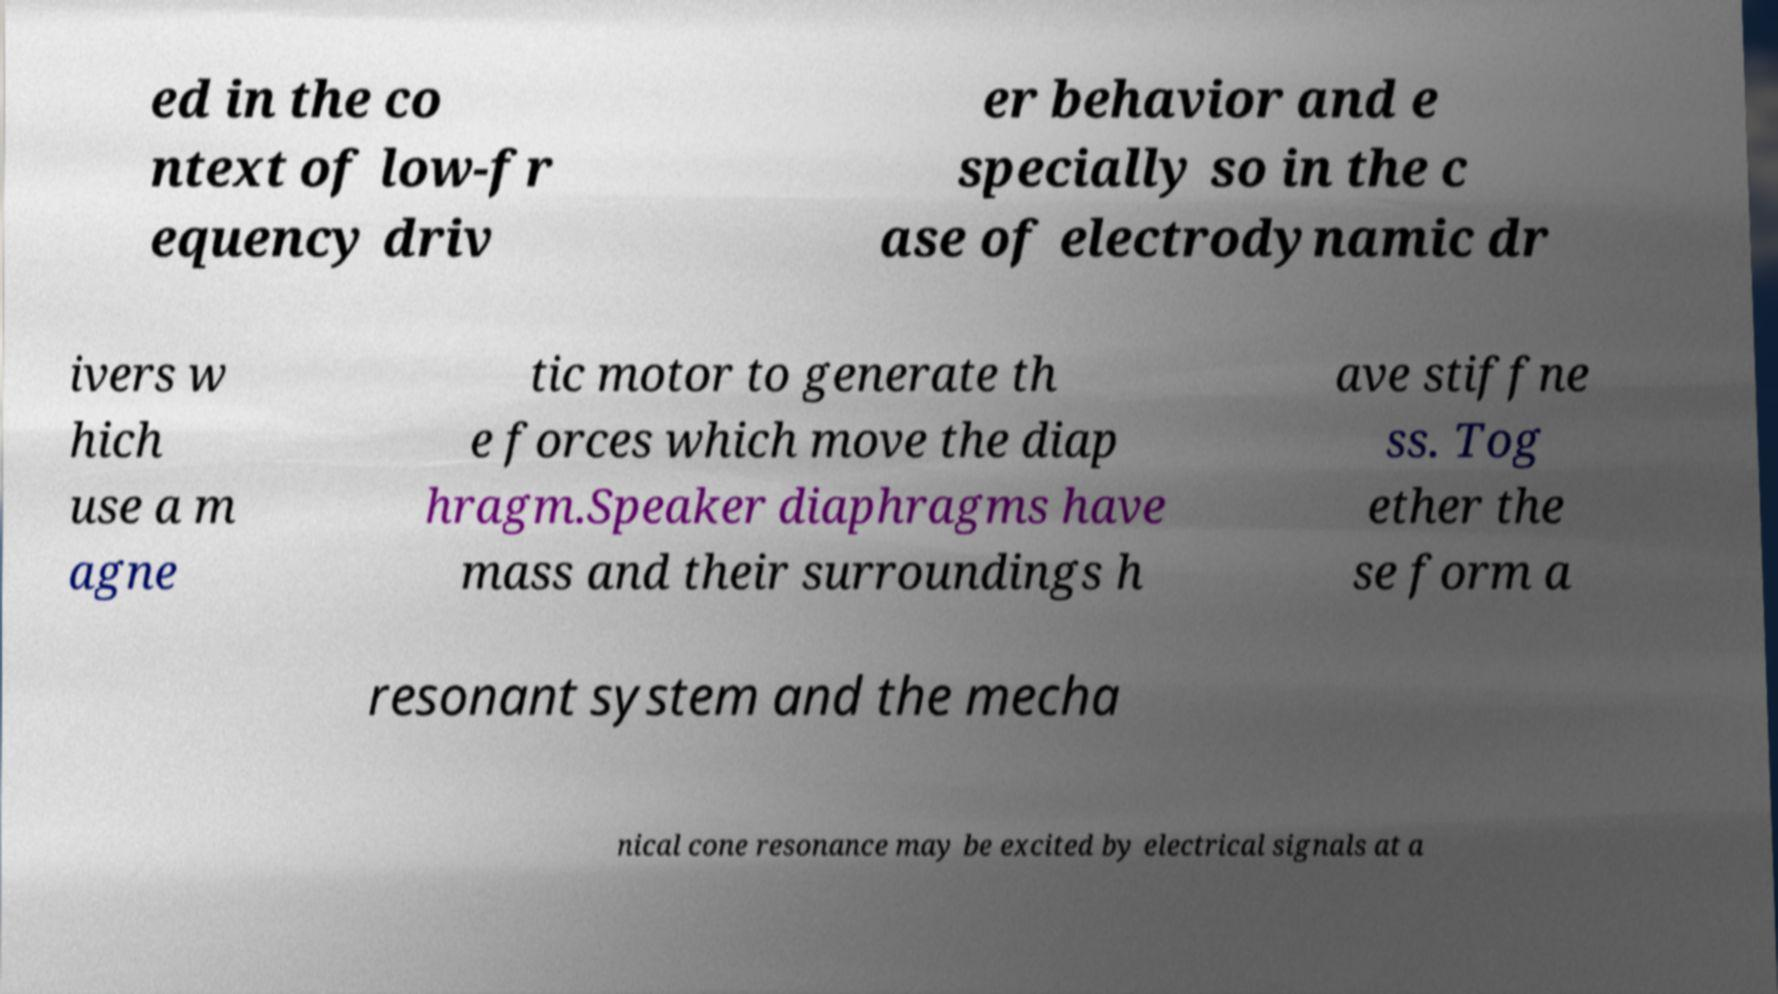I need the written content from this picture converted into text. Can you do that? ed in the co ntext of low-fr equency driv er behavior and e specially so in the c ase of electrodynamic dr ivers w hich use a m agne tic motor to generate th e forces which move the diap hragm.Speaker diaphragms have mass and their surroundings h ave stiffne ss. Tog ether the se form a resonant system and the mecha nical cone resonance may be excited by electrical signals at a 